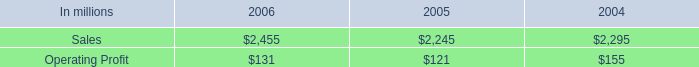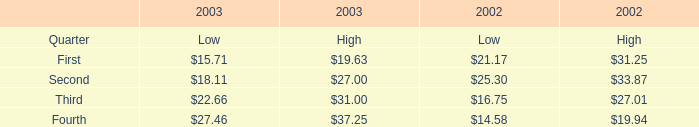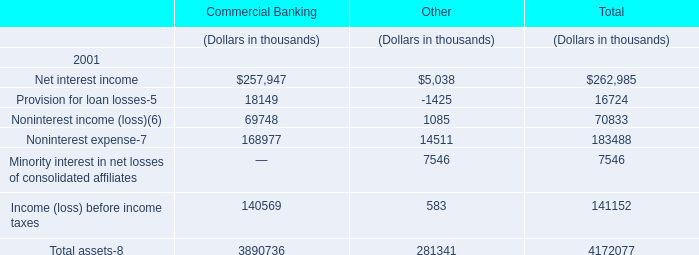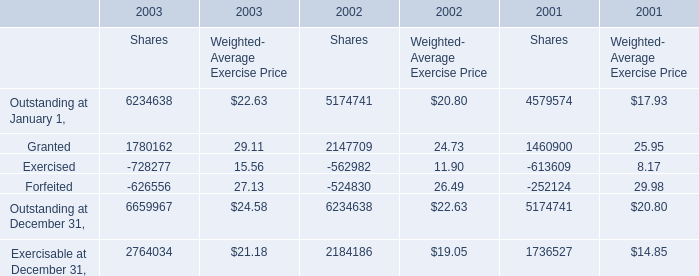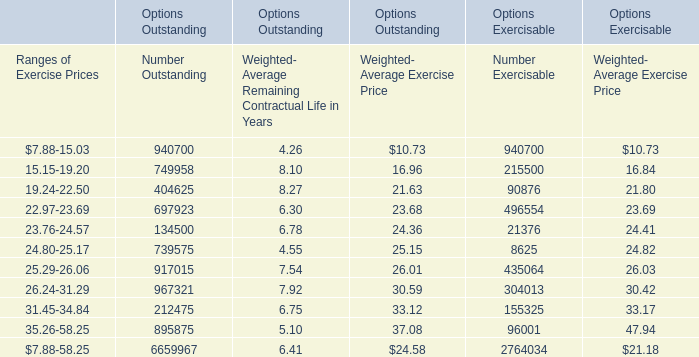What is the sum of Granted, Exercised and Forfeited for Shares in 2003 ? 
Computations: ((1780162 - 728277) - 626556)
Answer: 425329.0. 